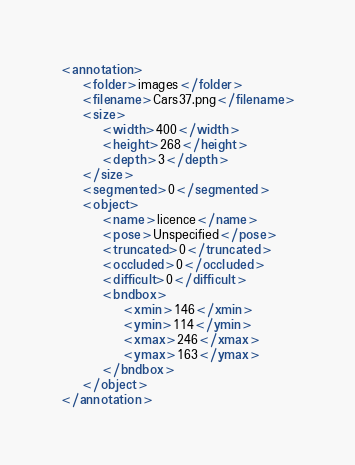<code> <loc_0><loc_0><loc_500><loc_500><_XML_>
<annotation>
    <folder>images</folder>
    <filename>Cars37.png</filename>
    <size>
        <width>400</width>
        <height>268</height>
        <depth>3</depth>
    </size>
    <segmented>0</segmented>
    <object>
        <name>licence</name>
        <pose>Unspecified</pose>
        <truncated>0</truncated>
        <occluded>0</occluded>
        <difficult>0</difficult>
        <bndbox>
            <xmin>146</xmin>
            <ymin>114</ymin>
            <xmax>246</xmax>
            <ymax>163</ymax>
        </bndbox>
    </object>
</annotation></code> 